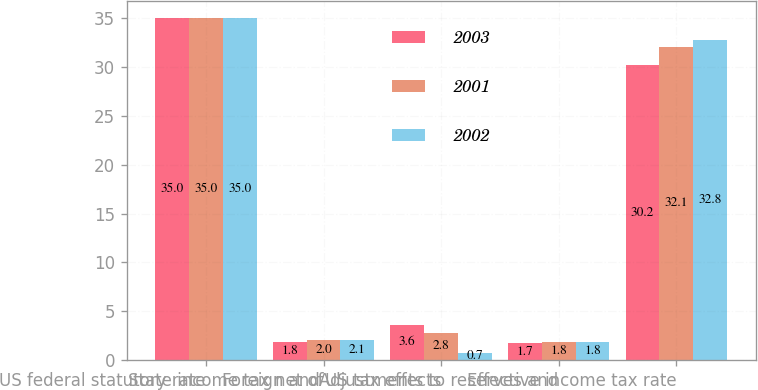Convert chart to OTSL. <chart><loc_0><loc_0><loc_500><loc_500><stacked_bar_chart><ecel><fcel>US federal statutory rate<fcel>State income tax net of<fcel>Foreign and US tax effects<fcel>Adjustments to reserves and<fcel>Effective income tax rate<nl><fcel>2003<fcel>35<fcel>1.8<fcel>3.6<fcel>1.7<fcel>30.2<nl><fcel>2001<fcel>35<fcel>2<fcel>2.8<fcel>1.8<fcel>32.1<nl><fcel>2002<fcel>35<fcel>2.1<fcel>0.7<fcel>1.8<fcel>32.8<nl></chart> 